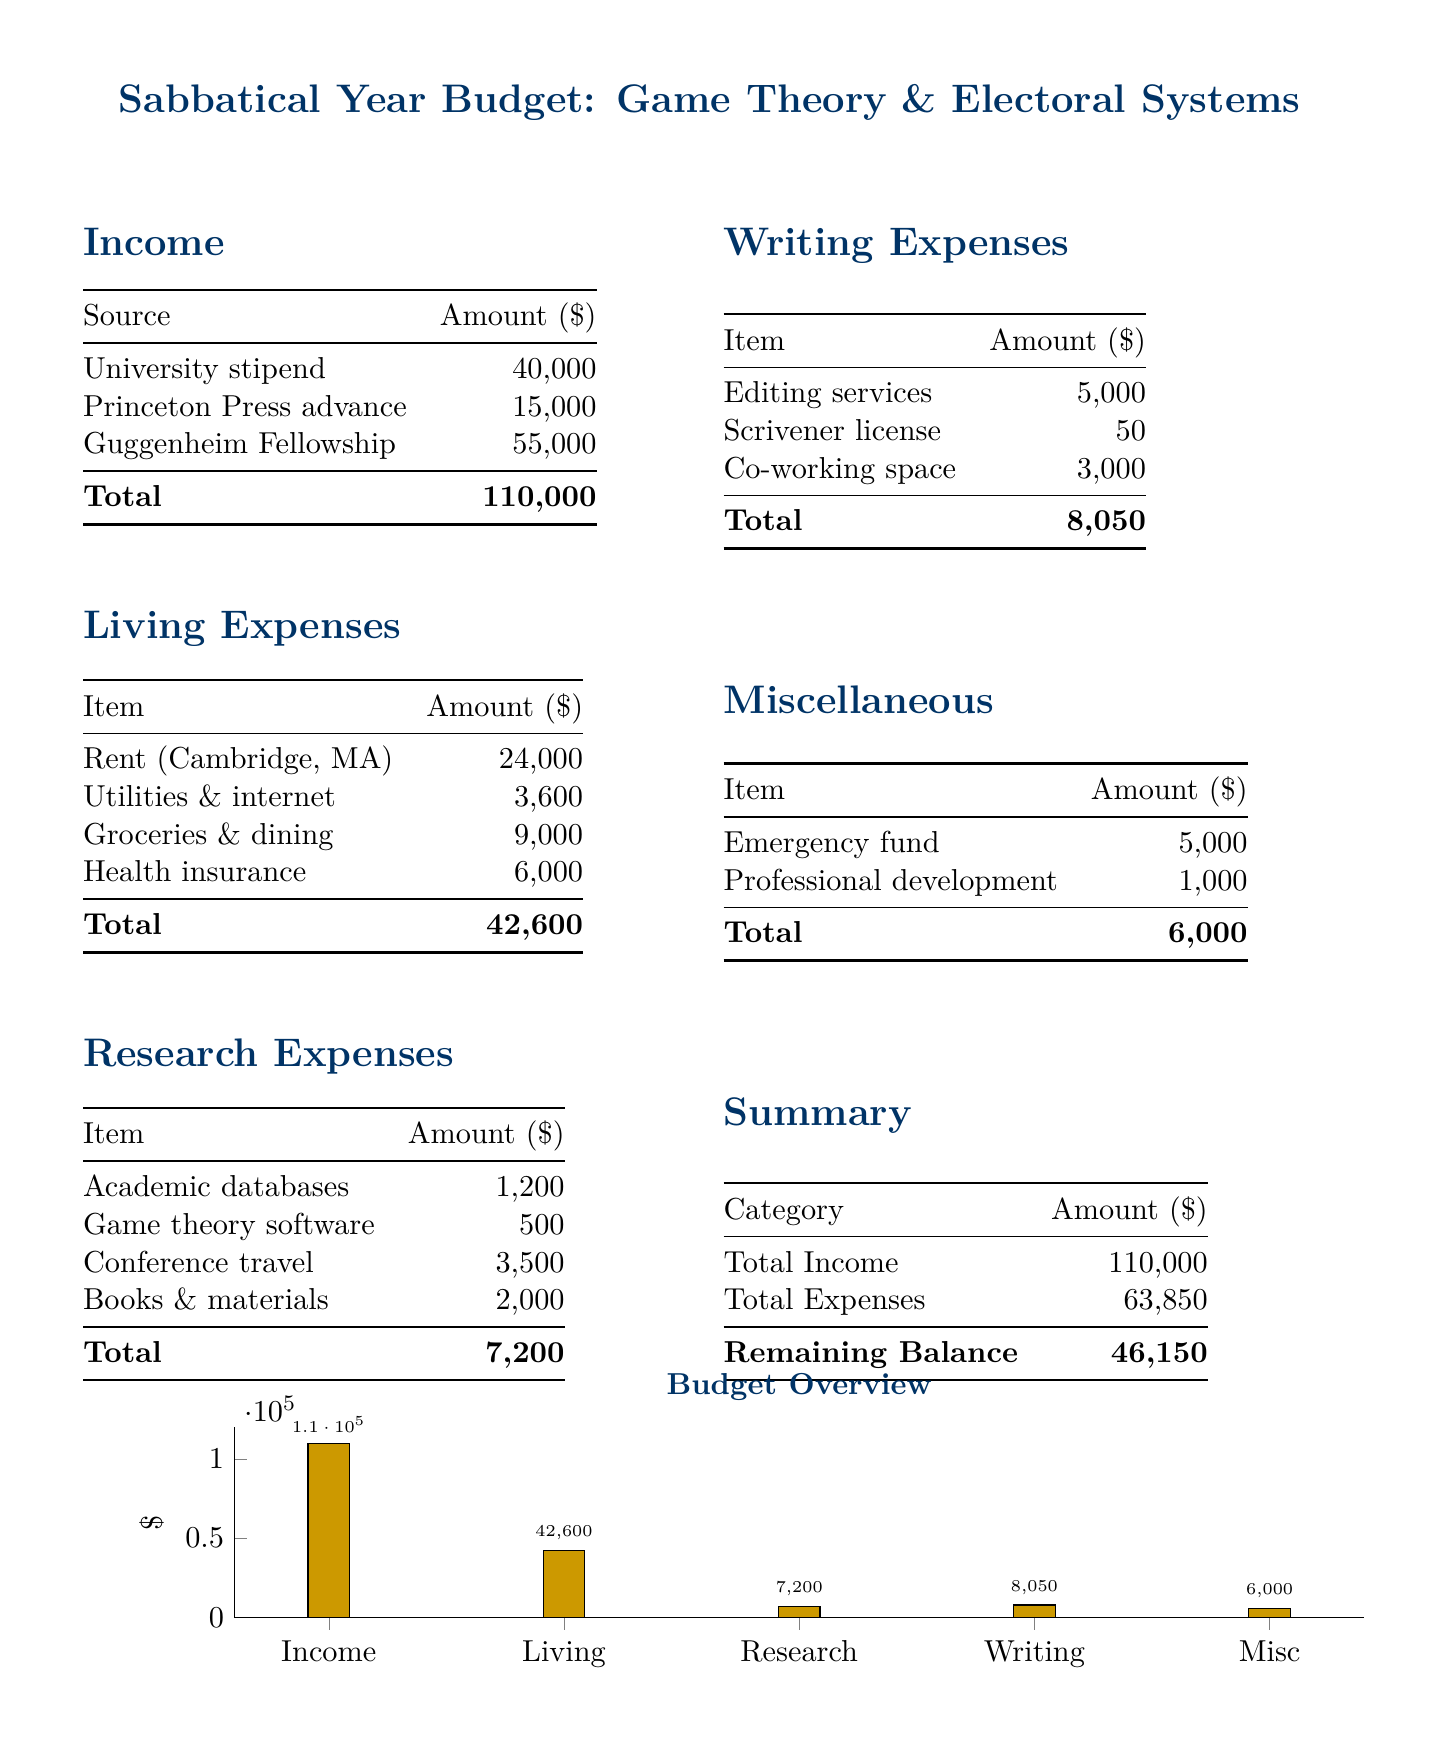What is the total income? The total income is the sum of all income sources listed, which is $40,000 + $15,000 + $55,000 = $110,000.
Answer: $110,000 What is the amount allocated for rent? The rent listed under living expenses is $24,000.
Answer: $24,000 How much is allocated for research expenses? The total research expenses are calculated from the items listed, which amounts to $7,200.
Answer: $7,200 What is the total for miscellaneous expenses? The total for miscellaneous expenses sums up to $6,000, composed of emergency fund and professional development.
Answer: $6,000 What is the remaining balance after expenses? The remaining balance is the difference between total income and total expenses, which is $110,000 - $63,850 = $46,150.
Answer: $46,150 What is the total amount spent on writing expenses? The total writing expenses, including editing services, license, and co-working space, account for $8,050.
Answer: $8,050 What is the largest source of income? The largest source of income listed is the Guggenheim Fellowship at $55,000.
Answer: Guggenheim Fellowship What expenses fall under research? Research expenses include academic databases, game theory software, conference travel, and books & materials.
Answer: Academic databases, game theory software, conference travel, books & materials What is the visual representation used in the document? The document uses a bar chart to visually represent the budget overview.
Answer: Bar chart 